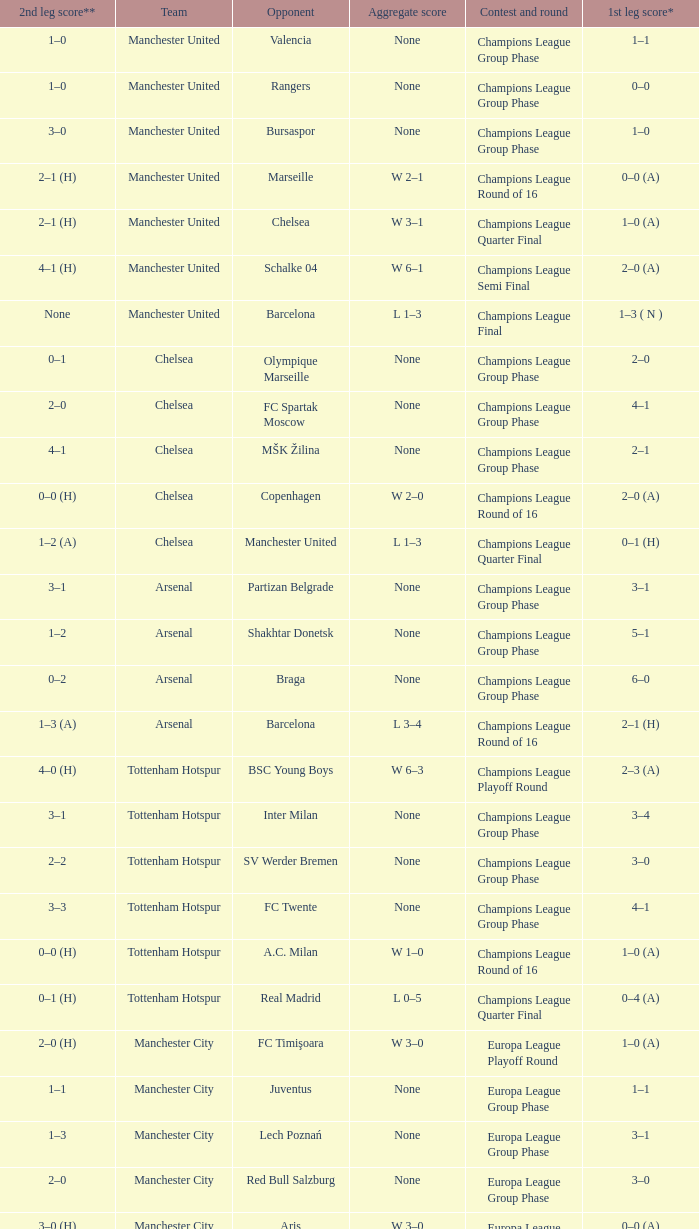How many goals did each one of the teams score in the first leg of the match between Liverpool and Trabzonspor? 1–0 (H). 